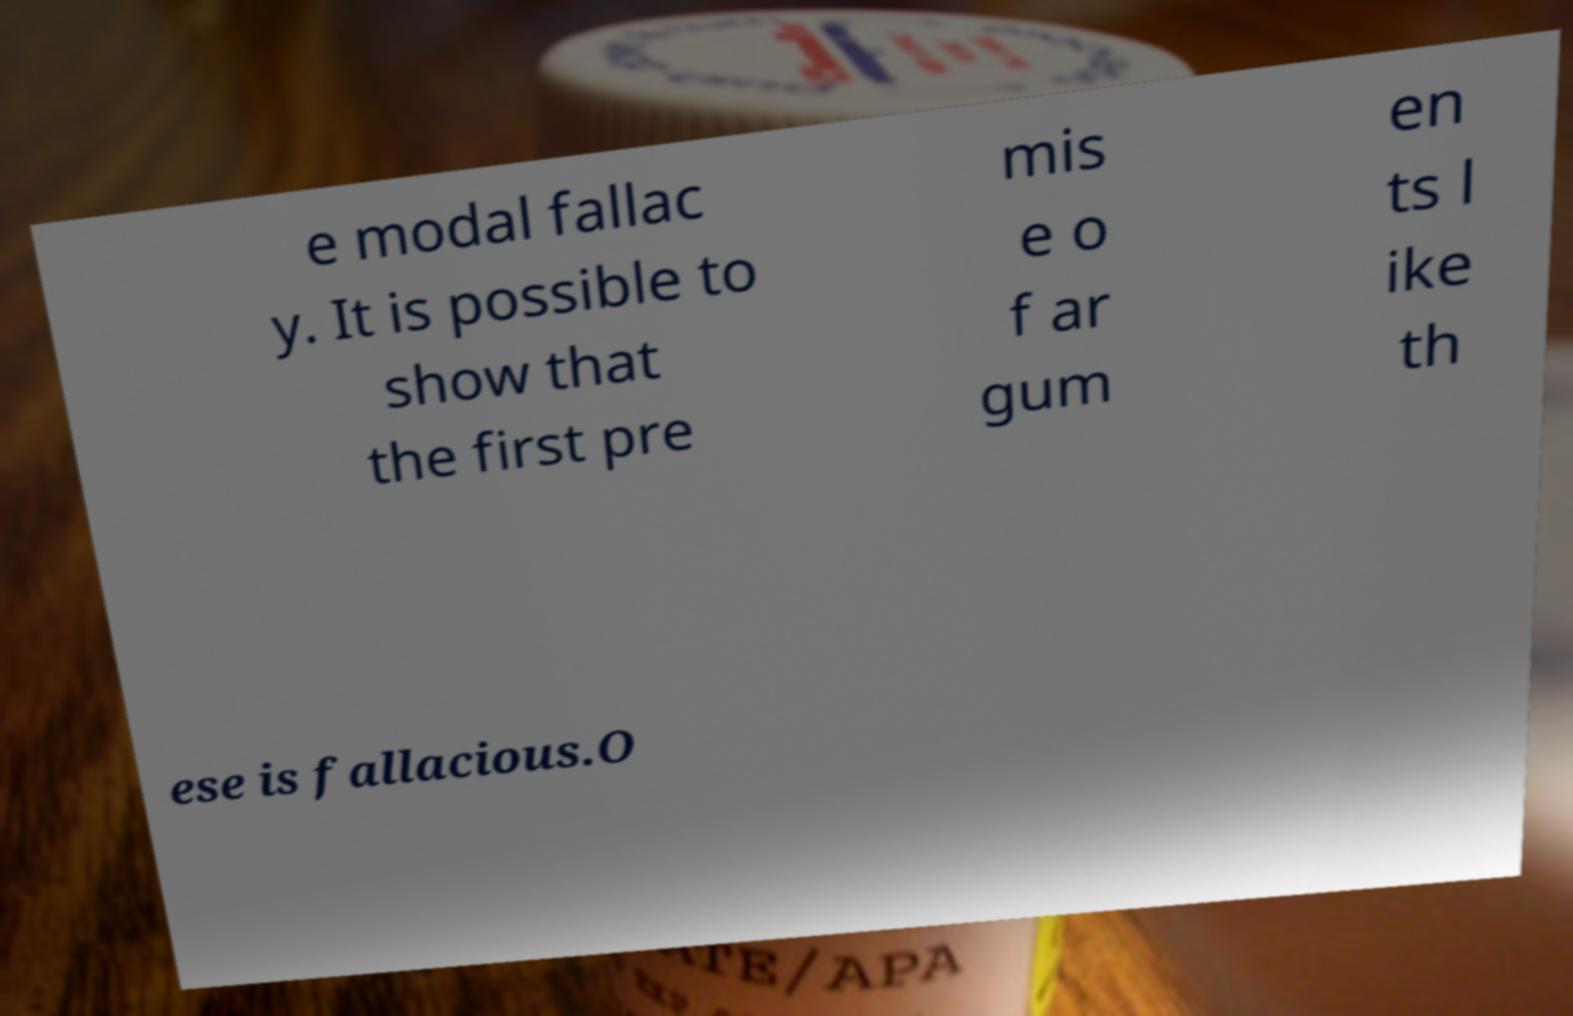Can you accurately transcribe the text from the provided image for me? e modal fallac y. It is possible to show that the first pre mis e o f ar gum en ts l ike th ese is fallacious.O 